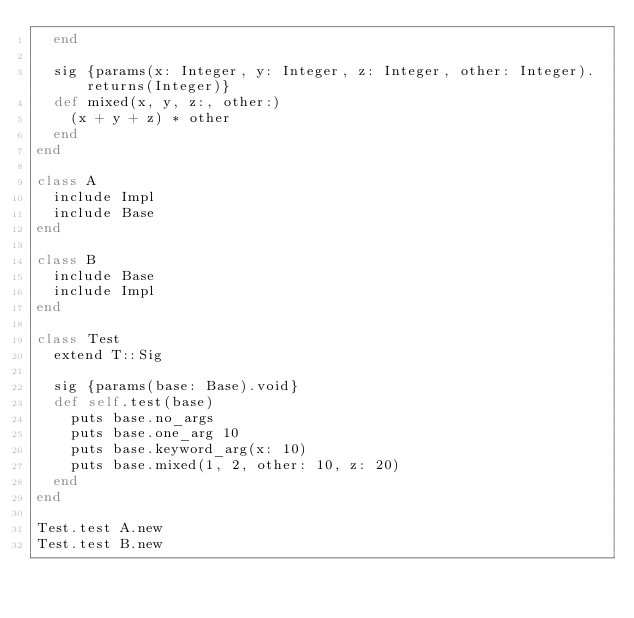<code> <loc_0><loc_0><loc_500><loc_500><_Ruby_>  end

  sig {params(x: Integer, y: Integer, z: Integer, other: Integer).returns(Integer)}
  def mixed(x, y, z:, other:)
    (x + y + z) * other
  end
end

class A
  include Impl
  include Base
end

class B
  include Base
  include Impl
end

class Test
  extend T::Sig

  sig {params(base: Base).void}
  def self.test(base)
    puts base.no_args
    puts base.one_arg 10
    puts base.keyword_arg(x: 10)
    puts base.mixed(1, 2, other: 10, z: 20)
  end
end

Test.test A.new
Test.test B.new
</code> 